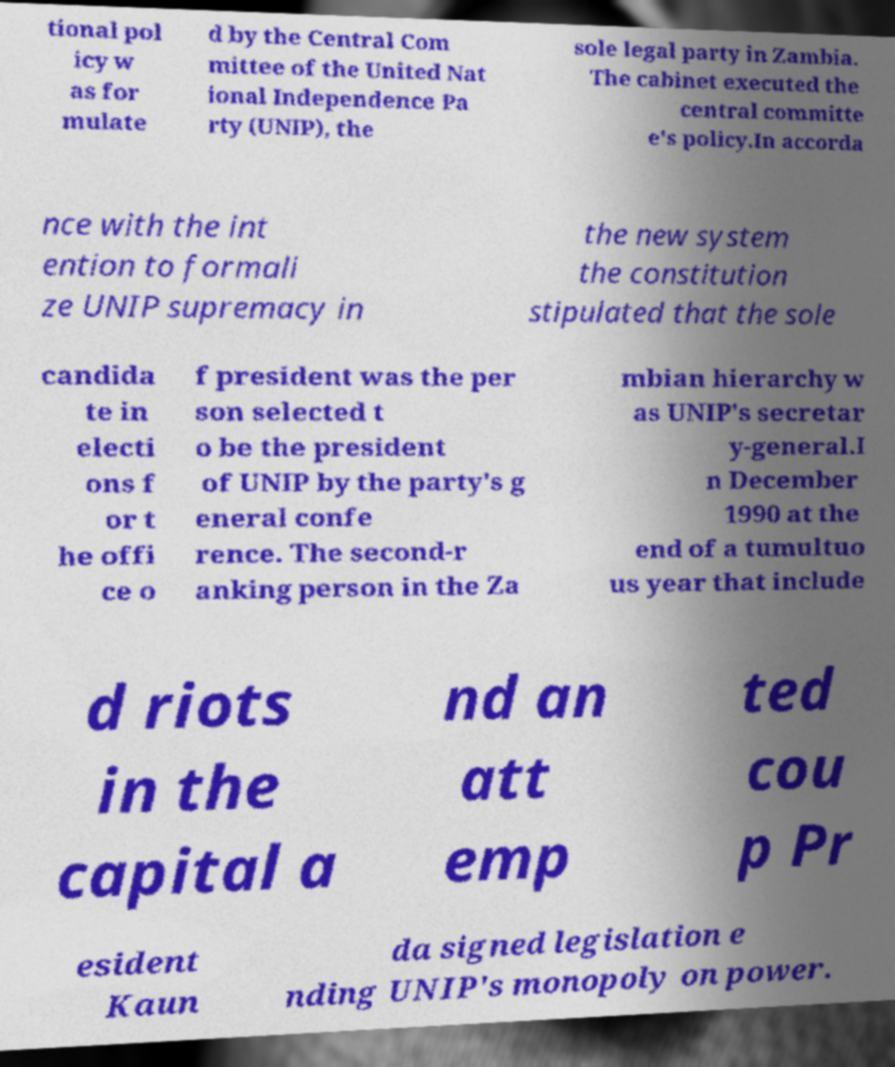Could you assist in decoding the text presented in this image and type it out clearly? tional pol icy w as for mulate d by the Central Com mittee of the United Nat ional Independence Pa rty (UNIP), the sole legal party in Zambia. The cabinet executed the central committe e's policy.In accorda nce with the int ention to formali ze UNIP supremacy in the new system the constitution stipulated that the sole candida te in electi ons f or t he offi ce o f president was the per son selected t o be the president of UNIP by the party's g eneral confe rence. The second-r anking person in the Za mbian hierarchy w as UNIP's secretar y-general.I n December 1990 at the end of a tumultuo us year that include d riots in the capital a nd an att emp ted cou p Pr esident Kaun da signed legislation e nding UNIP's monopoly on power. 